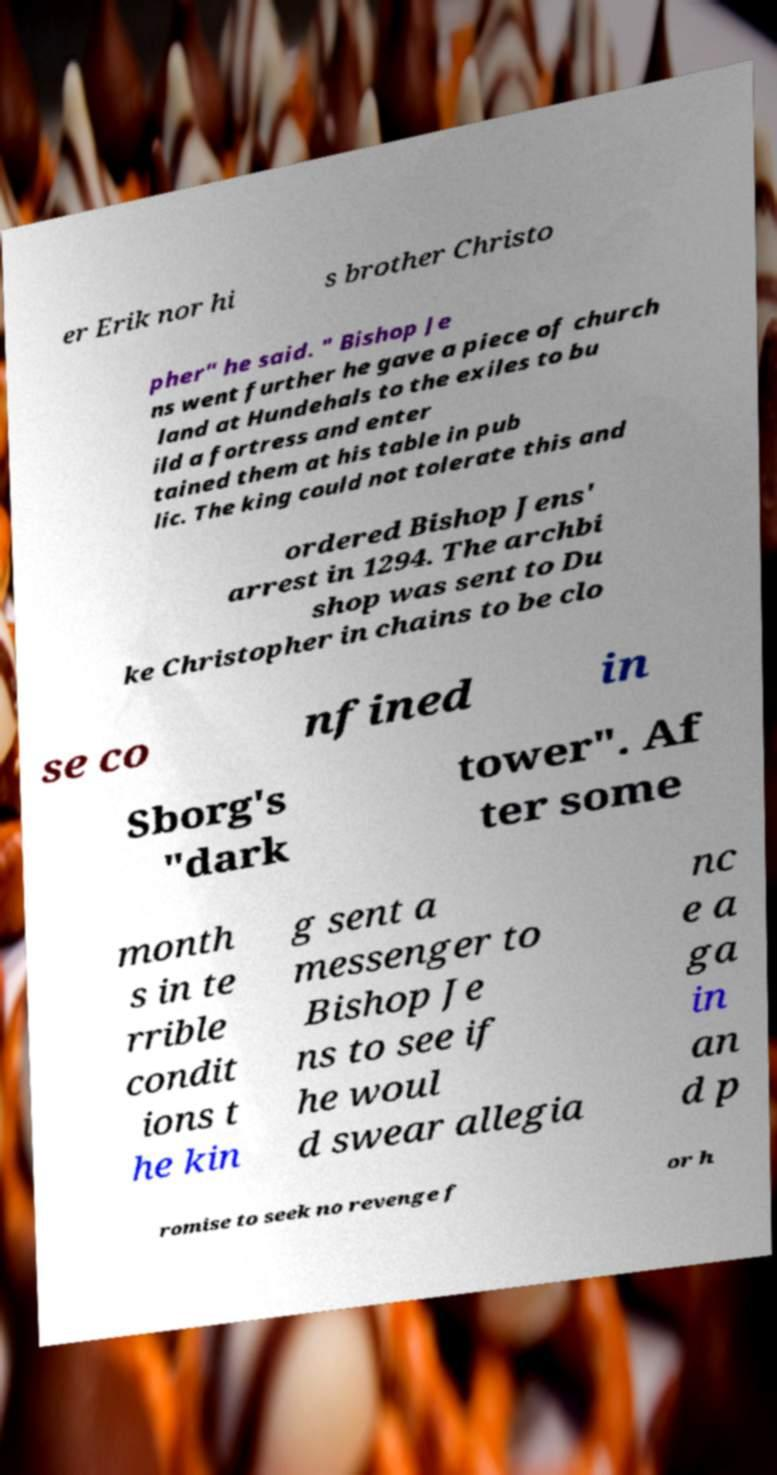Please read and relay the text visible in this image. What does it say? er Erik nor hi s brother Christo pher" he said. " Bishop Je ns went further he gave a piece of church land at Hundehals to the exiles to bu ild a fortress and enter tained them at his table in pub lic. The king could not tolerate this and ordered Bishop Jens' arrest in 1294. The archbi shop was sent to Du ke Christopher in chains to be clo se co nfined in Sborg's "dark tower". Af ter some month s in te rrible condit ions t he kin g sent a messenger to Bishop Je ns to see if he woul d swear allegia nc e a ga in an d p romise to seek no revenge f or h 